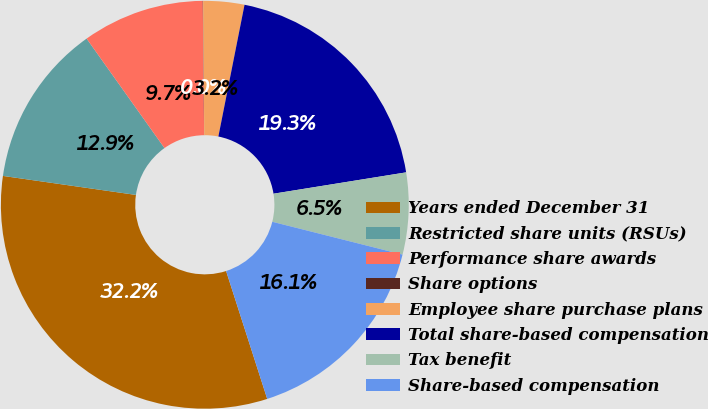Convert chart to OTSL. <chart><loc_0><loc_0><loc_500><loc_500><pie_chart><fcel>Years ended December 31<fcel>Restricted share units (RSUs)<fcel>Performance share awards<fcel>Share options<fcel>Employee share purchase plans<fcel>Total share-based compensation<fcel>Tax benefit<fcel>Share-based compensation<nl><fcel>32.21%<fcel>12.9%<fcel>9.68%<fcel>0.03%<fcel>3.25%<fcel>19.34%<fcel>6.47%<fcel>16.12%<nl></chart> 